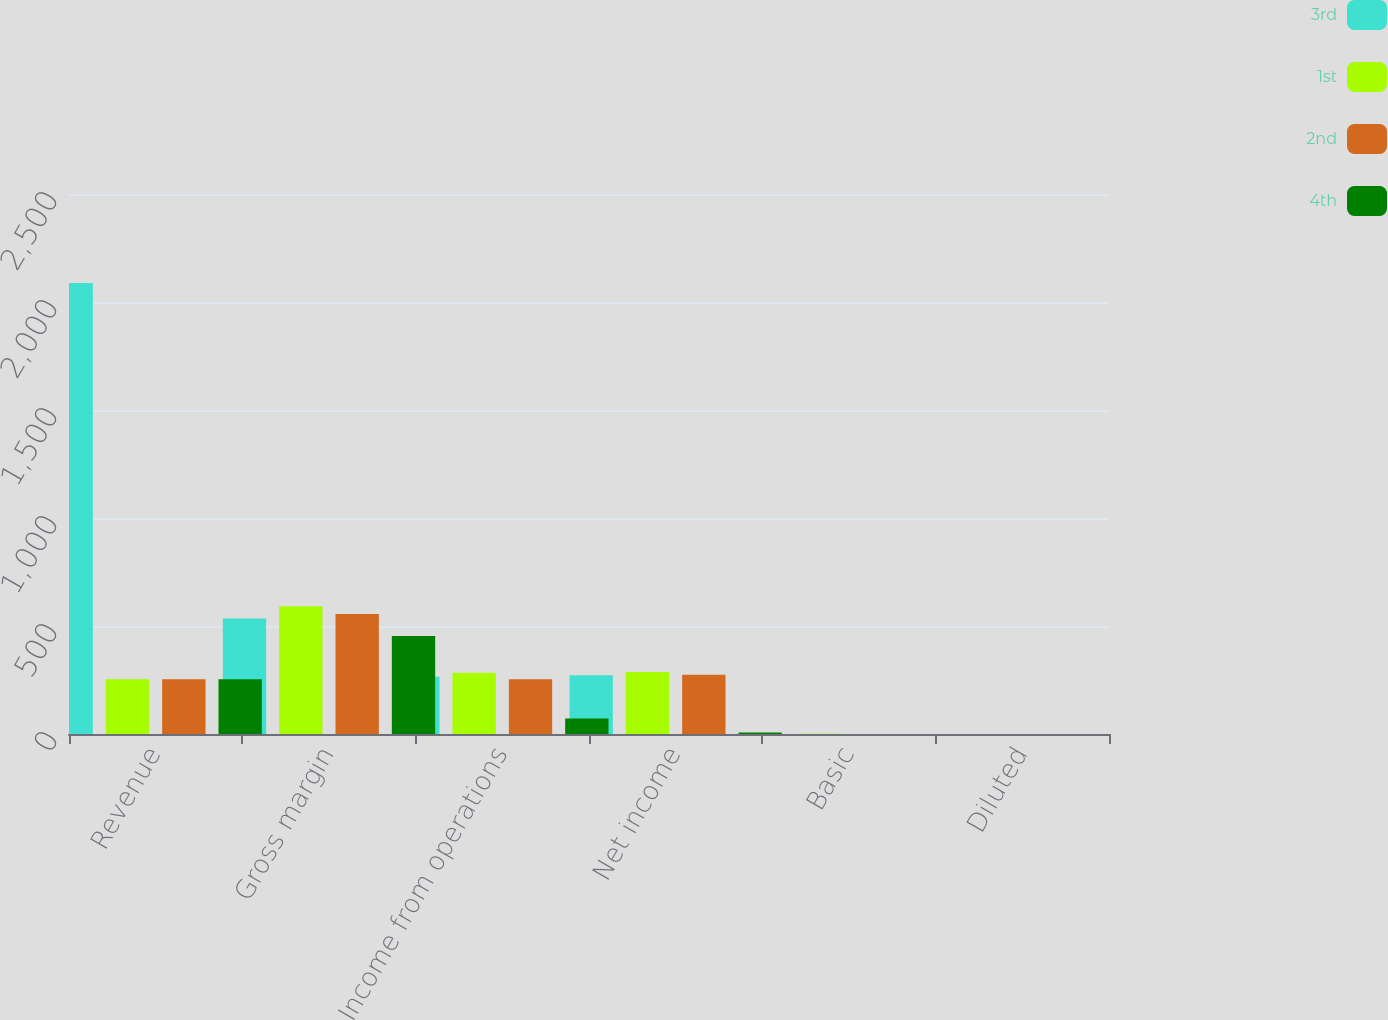Convert chart to OTSL. <chart><loc_0><loc_0><loc_500><loc_500><stacked_bar_chart><ecel><fcel>Revenue<fcel>Gross margin<fcel>Income from operations<fcel>Net income<fcel>Basic<fcel>Diluted<nl><fcel>3rd<fcel>2088<fcel>535<fcel>265<fcel>272<fcel>0.57<fcel>0.54<nl><fcel>1st<fcel>253<fcel>591<fcel>284<fcel>287<fcel>0.6<fcel>0.57<nl><fcel>2nd<fcel>253<fcel>556<fcel>253<fcel>274<fcel>0.56<fcel>0.53<nl><fcel>4th<fcel>253<fcel>454<fcel>72<fcel>7<fcel>0.01<fcel>0.01<nl></chart> 